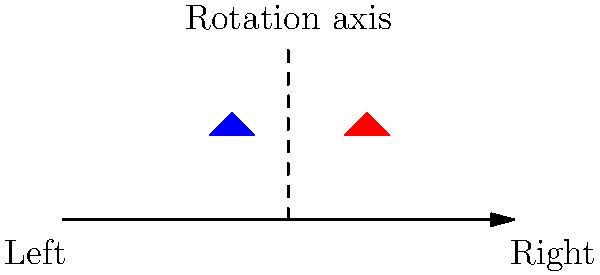Looking at the simplified logos of the Democratic (blue) and Republican (red) parties, what type of symmetry transformation would map one party's logo onto the other's position while maintaining the overall left-right political spectrum orientation? Let's approach this step-by-step:

1. First, observe the positions of the logos:
   - The Democratic (blue) logo is on the left side.
   - The Republican (red) logo is on the right side.

2. Note the shape of each logo:
   - The Democratic logo is a leftward-pointing triangle.
   - The Republican logo is a rightward-pointing triangle.

3. Consider the political spectrum:
   - Left is typically associated with Democrats.
   - Right is typically associated with Republicans.

4. To maintain this left-right orientation, we can't simply translate one logo to the other's position.

5. A reflection would flip the orientation, which doesn't preserve the political spectrum.

6. The key is to find a transformation that:
   - Moves each logo to the opposite side.
   - Keeps the Democratic logo pointing left and the Republican logo pointing right.

7. A 180-degree rotation around the central vertical axis accomplishes this:
   - It swaps the positions of the logos.
   - It maintains the leftward and rightward orientations of the triangles.
   - It preserves the left-right political spectrum association.

Therefore, a 180-degree rotation (or point reflection) around the central vertical axis is the appropriate symmetry transformation.
Answer: 180-degree rotation 